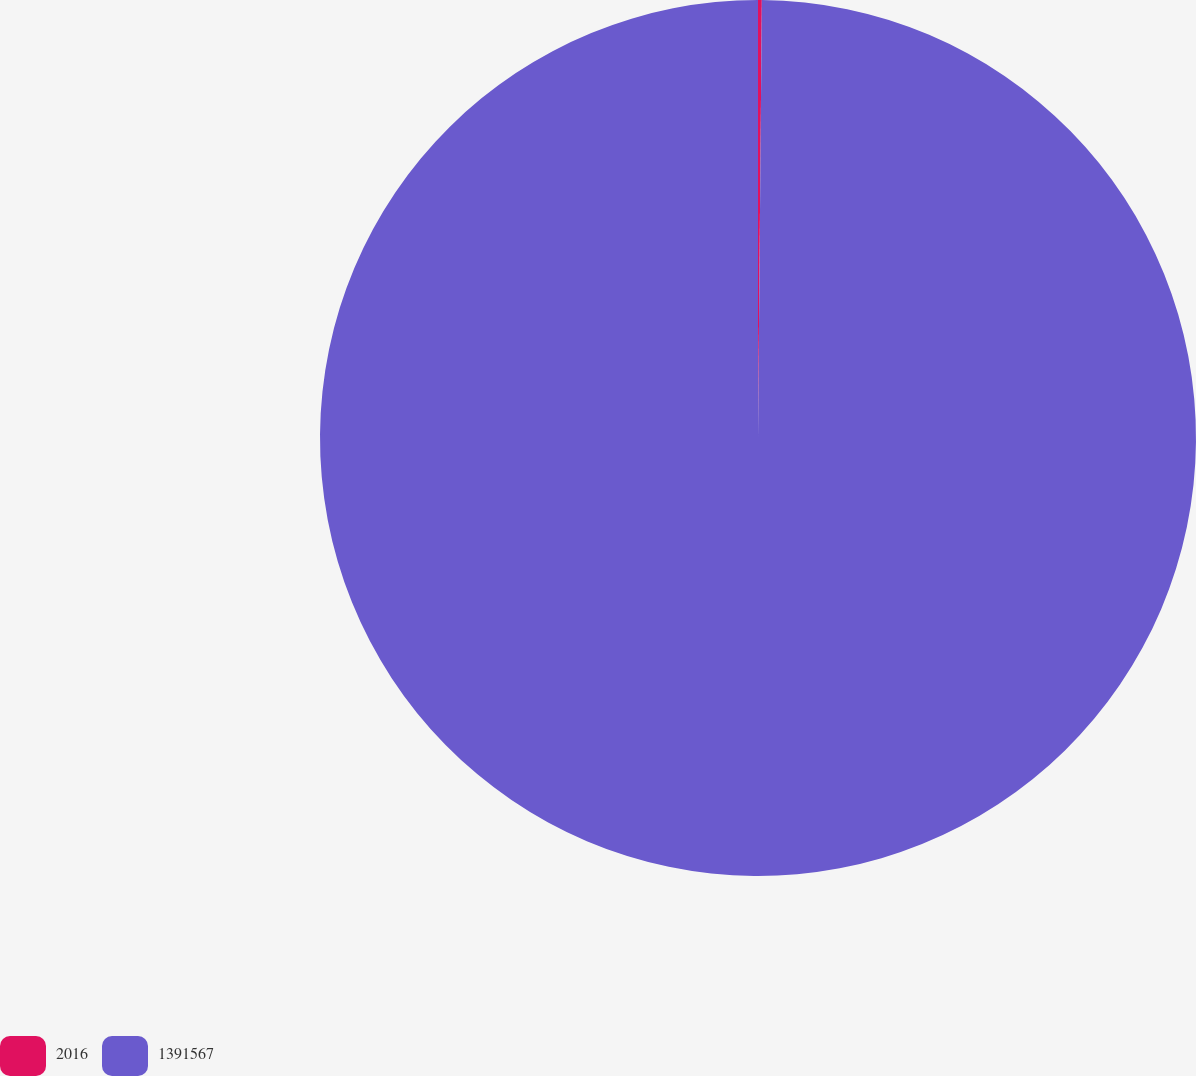<chart> <loc_0><loc_0><loc_500><loc_500><pie_chart><fcel>2016<fcel>1391567<nl><fcel>0.14%<fcel>99.86%<nl></chart> 